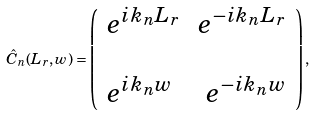<formula> <loc_0><loc_0><loc_500><loc_500>\hat { C } _ { n } ( L _ { r } , w ) = \left ( \begin{array} { l r } e ^ { i k _ { n } L _ { r } } & e ^ { - i k _ { n } L _ { r } } \\ \ \\ e ^ { i k _ { n } w } & e ^ { - i k _ { n } w } \\ \end{array} \right ) ,</formula> 